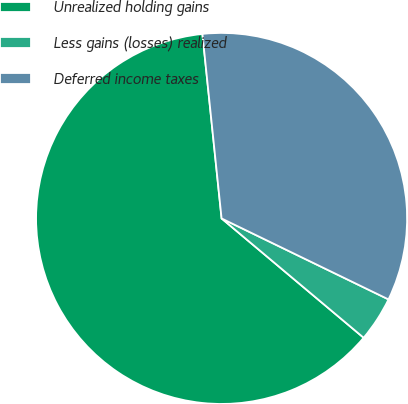Convert chart. <chart><loc_0><loc_0><loc_500><loc_500><pie_chart><fcel>Unrealized holding gains<fcel>Less gains (losses) realized<fcel>Deferred income taxes<nl><fcel>62.24%<fcel>3.93%<fcel>33.84%<nl></chart> 